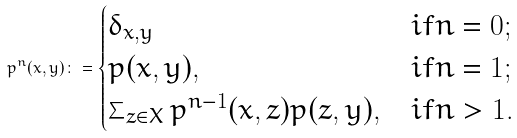<formula> <loc_0><loc_0><loc_500><loc_500>p ^ { n } ( x , y ) \colon = \begin{cases} \delta _ { x , y } & i f n = 0 ; \\ p ( x , y ) , & i f n = 1 ; \\ \sum _ { z \in X } p ^ { n - 1 } ( x , z ) p ( z , y ) , & i f n > 1 . \end{cases}</formula> 